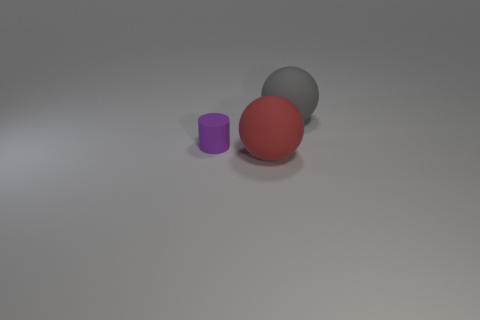What number of other objects are the same color as the small thing?
Ensure brevity in your answer.  0. What color is the tiny cylinder?
Keep it short and to the point. Purple. How many gray objects have the same shape as the large red object?
Your response must be concise. 1. How many things are small purple objects or matte objects on the right side of the small purple thing?
Your answer should be compact. 3. Do the tiny object and the big ball left of the gray sphere have the same color?
Keep it short and to the point. No. There is a object that is both left of the gray matte sphere and behind the red thing; what size is it?
Make the answer very short. Small. Are there any red things behind the large red object?
Offer a terse response. No. There is a rubber ball that is in front of the tiny purple thing; are there any large gray matte balls in front of it?
Keep it short and to the point. No. Are there an equal number of big balls that are to the left of the big gray thing and large things behind the red matte sphere?
Offer a terse response. Yes. What is the color of the cylinder that is made of the same material as the gray ball?
Offer a terse response. Purple. 